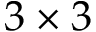<formula> <loc_0><loc_0><loc_500><loc_500>3 \times 3</formula> 